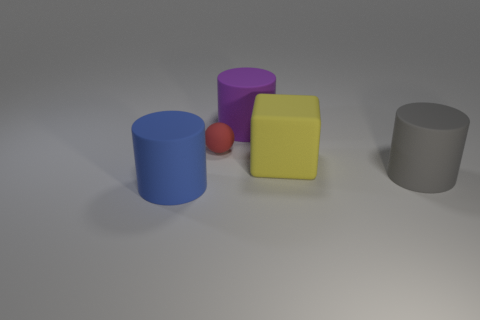Can you describe the objects and their arrangement? The image shows a collection of geometric shapes orderly arranged. There's a blue cylinder, a big yellow cube, a small red sphere, a violet half-cylinder, and a grey cylinder all resting on a flat surface under a neutral light. 